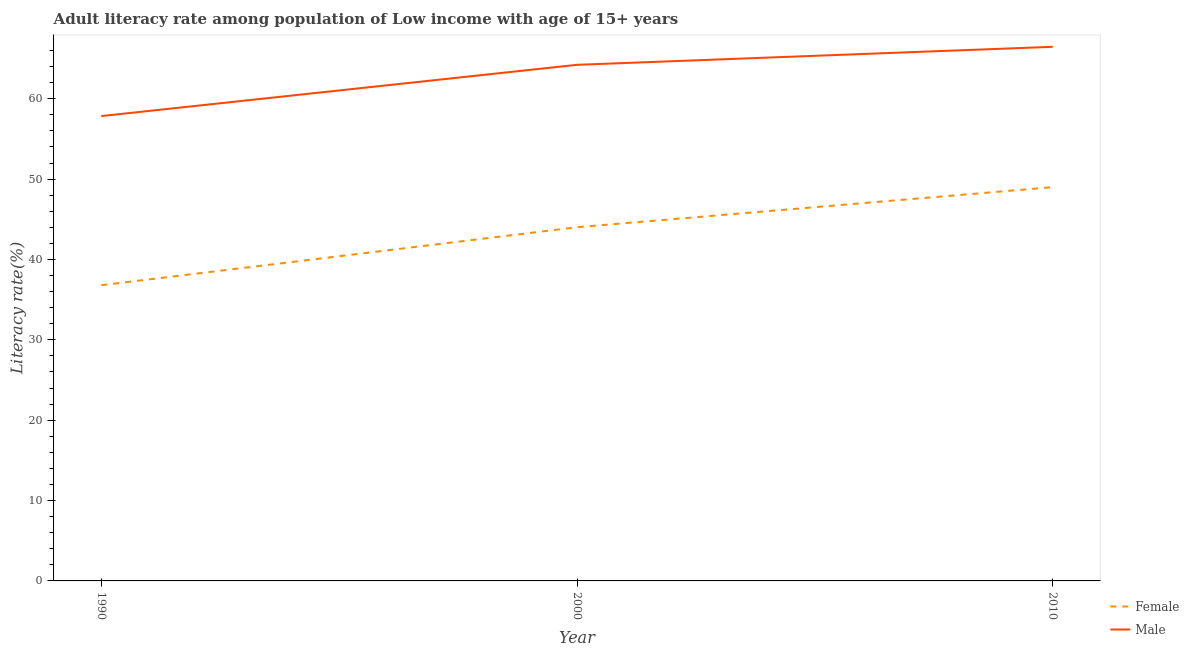Is the number of lines equal to the number of legend labels?
Give a very brief answer. Yes. What is the female adult literacy rate in 2010?
Your response must be concise. 49. Across all years, what is the maximum male adult literacy rate?
Your answer should be very brief. 66.46. Across all years, what is the minimum male adult literacy rate?
Give a very brief answer. 57.84. What is the total male adult literacy rate in the graph?
Offer a very short reply. 188.52. What is the difference between the male adult literacy rate in 2000 and that in 2010?
Your answer should be compact. -2.24. What is the difference between the male adult literacy rate in 1990 and the female adult literacy rate in 2000?
Your response must be concise. 13.83. What is the average female adult literacy rate per year?
Provide a short and direct response. 43.27. In the year 2010, what is the difference between the male adult literacy rate and female adult literacy rate?
Your answer should be compact. 17.46. What is the ratio of the male adult literacy rate in 1990 to that in 2010?
Ensure brevity in your answer.  0.87. Is the difference between the female adult literacy rate in 1990 and 2010 greater than the difference between the male adult literacy rate in 1990 and 2010?
Provide a short and direct response. No. What is the difference between the highest and the second highest male adult literacy rate?
Provide a short and direct response. 2.24. What is the difference between the highest and the lowest male adult literacy rate?
Offer a very short reply. 8.62. In how many years, is the female adult literacy rate greater than the average female adult literacy rate taken over all years?
Offer a very short reply. 2. Is the sum of the female adult literacy rate in 2000 and 2010 greater than the maximum male adult literacy rate across all years?
Offer a very short reply. Yes. Does the female adult literacy rate monotonically increase over the years?
Your response must be concise. Yes. Are the values on the major ticks of Y-axis written in scientific E-notation?
Provide a succinct answer. No. Where does the legend appear in the graph?
Your answer should be very brief. Bottom right. What is the title of the graph?
Your response must be concise. Adult literacy rate among population of Low income with age of 15+ years. What is the label or title of the Y-axis?
Keep it short and to the point. Literacy rate(%). What is the Literacy rate(%) in Female in 1990?
Make the answer very short. 36.79. What is the Literacy rate(%) of Male in 1990?
Your answer should be very brief. 57.84. What is the Literacy rate(%) of Female in 2000?
Offer a very short reply. 44.01. What is the Literacy rate(%) of Male in 2000?
Offer a terse response. 64.22. What is the Literacy rate(%) in Female in 2010?
Provide a short and direct response. 49. What is the Literacy rate(%) in Male in 2010?
Your answer should be very brief. 66.46. Across all years, what is the maximum Literacy rate(%) of Female?
Provide a succinct answer. 49. Across all years, what is the maximum Literacy rate(%) of Male?
Give a very brief answer. 66.46. Across all years, what is the minimum Literacy rate(%) of Female?
Offer a very short reply. 36.79. Across all years, what is the minimum Literacy rate(%) of Male?
Your answer should be very brief. 57.84. What is the total Literacy rate(%) in Female in the graph?
Provide a short and direct response. 129.8. What is the total Literacy rate(%) in Male in the graph?
Your answer should be compact. 188.52. What is the difference between the Literacy rate(%) in Female in 1990 and that in 2000?
Your response must be concise. -7.22. What is the difference between the Literacy rate(%) of Male in 1990 and that in 2000?
Offer a very short reply. -6.38. What is the difference between the Literacy rate(%) in Female in 1990 and that in 2010?
Your answer should be compact. -12.21. What is the difference between the Literacy rate(%) in Male in 1990 and that in 2010?
Provide a succinct answer. -8.62. What is the difference between the Literacy rate(%) in Female in 2000 and that in 2010?
Offer a terse response. -4.99. What is the difference between the Literacy rate(%) of Male in 2000 and that in 2010?
Provide a succinct answer. -2.24. What is the difference between the Literacy rate(%) of Female in 1990 and the Literacy rate(%) of Male in 2000?
Your response must be concise. -27.43. What is the difference between the Literacy rate(%) of Female in 1990 and the Literacy rate(%) of Male in 2010?
Offer a very short reply. -29.67. What is the difference between the Literacy rate(%) in Female in 2000 and the Literacy rate(%) in Male in 2010?
Your answer should be very brief. -22.45. What is the average Literacy rate(%) of Female per year?
Ensure brevity in your answer.  43.27. What is the average Literacy rate(%) of Male per year?
Keep it short and to the point. 62.84. In the year 1990, what is the difference between the Literacy rate(%) in Female and Literacy rate(%) in Male?
Provide a short and direct response. -21.05. In the year 2000, what is the difference between the Literacy rate(%) in Female and Literacy rate(%) in Male?
Ensure brevity in your answer.  -20.21. In the year 2010, what is the difference between the Literacy rate(%) of Female and Literacy rate(%) of Male?
Ensure brevity in your answer.  -17.46. What is the ratio of the Literacy rate(%) in Female in 1990 to that in 2000?
Make the answer very short. 0.84. What is the ratio of the Literacy rate(%) of Male in 1990 to that in 2000?
Offer a very short reply. 0.9. What is the ratio of the Literacy rate(%) in Female in 1990 to that in 2010?
Your answer should be compact. 0.75. What is the ratio of the Literacy rate(%) in Male in 1990 to that in 2010?
Provide a short and direct response. 0.87. What is the ratio of the Literacy rate(%) of Female in 2000 to that in 2010?
Offer a terse response. 0.9. What is the ratio of the Literacy rate(%) of Male in 2000 to that in 2010?
Provide a short and direct response. 0.97. What is the difference between the highest and the second highest Literacy rate(%) in Female?
Provide a succinct answer. 4.99. What is the difference between the highest and the second highest Literacy rate(%) of Male?
Your answer should be very brief. 2.24. What is the difference between the highest and the lowest Literacy rate(%) in Female?
Offer a terse response. 12.21. What is the difference between the highest and the lowest Literacy rate(%) of Male?
Ensure brevity in your answer.  8.62. 